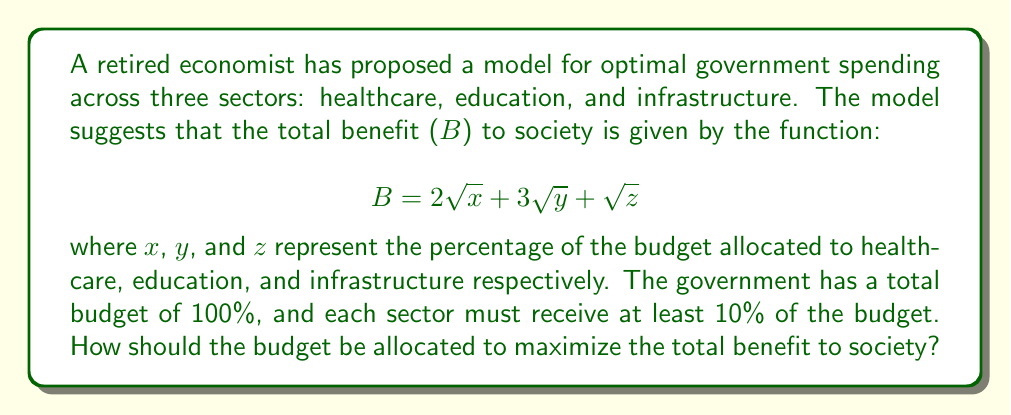Can you answer this question? To solve this optimization problem, we can use the method of Lagrange multipliers. Here's a step-by-step approach:

1) First, we set up the constraint equation:
   $$x + y + z = 100$$
   
2) We also have the inequality constraints:
   $$x \geq 10, y \geq 10, z \geq 10$$

3) The Lagrangian function is:
   $$L = 2\sqrt{x} + 3\sqrt{y} + \sqrt{z} - \lambda(x + y + z - 100)$$

4) We take partial derivatives and set them equal to zero:
   $$\frac{\partial L}{\partial x} = \frac{1}{\sqrt{x}} - \lambda = 0$$
   $$\frac{\partial L}{\partial y} = \frac{3}{2\sqrt{y}} - \lambda = 0$$
   $$\frac{\partial L}{\partial z} = \frac{1}{2\sqrt{z}} - \lambda = 0$$
   $$\frac{\partial L}{\partial \lambda} = x + y + z - 100 = 0$$

5) From these equations, we can derive:
   $$\sqrt{x} = \frac{1}{\lambda}$$
   $$\sqrt{y} = \frac{3}{2\lambda}$$
   $$\sqrt{z} = \frac{1}{2\lambda}$$

6) Substituting these into the constraint equation:
   $$\frac{1}{\lambda^2} + \frac{9}{4\lambda^2} + \frac{1}{4\lambda^2} = 100$$
   $$\frac{16}{4\lambda^2} = 100$$
   $$\lambda = \frac{1}{5}$$

7) Now we can solve for x, y, and z:
   $$x = 25, y = 56.25, z = 18.75$$

8) However, we need to check our inequality constraints. Since z < 10, we need to adjust our solution.

9) We set z = 10 and solve the system again:
   $$2\sqrt{x} + 3\sqrt{y} + \sqrt{10} = \lambda(x + y + 10)$$
   $$x + y = 90$$

10) Solving this system yields:
    $$x \approx 28.24, y \approx 61.76, z = 10$$

This solution satisfies all constraints and maximizes the benefit function.
Answer: The optimal allocation of the government budget is approximately:
Healthcare (x): 28.24%
Education (y): 61.76%
Infrastructure (z): 10% 